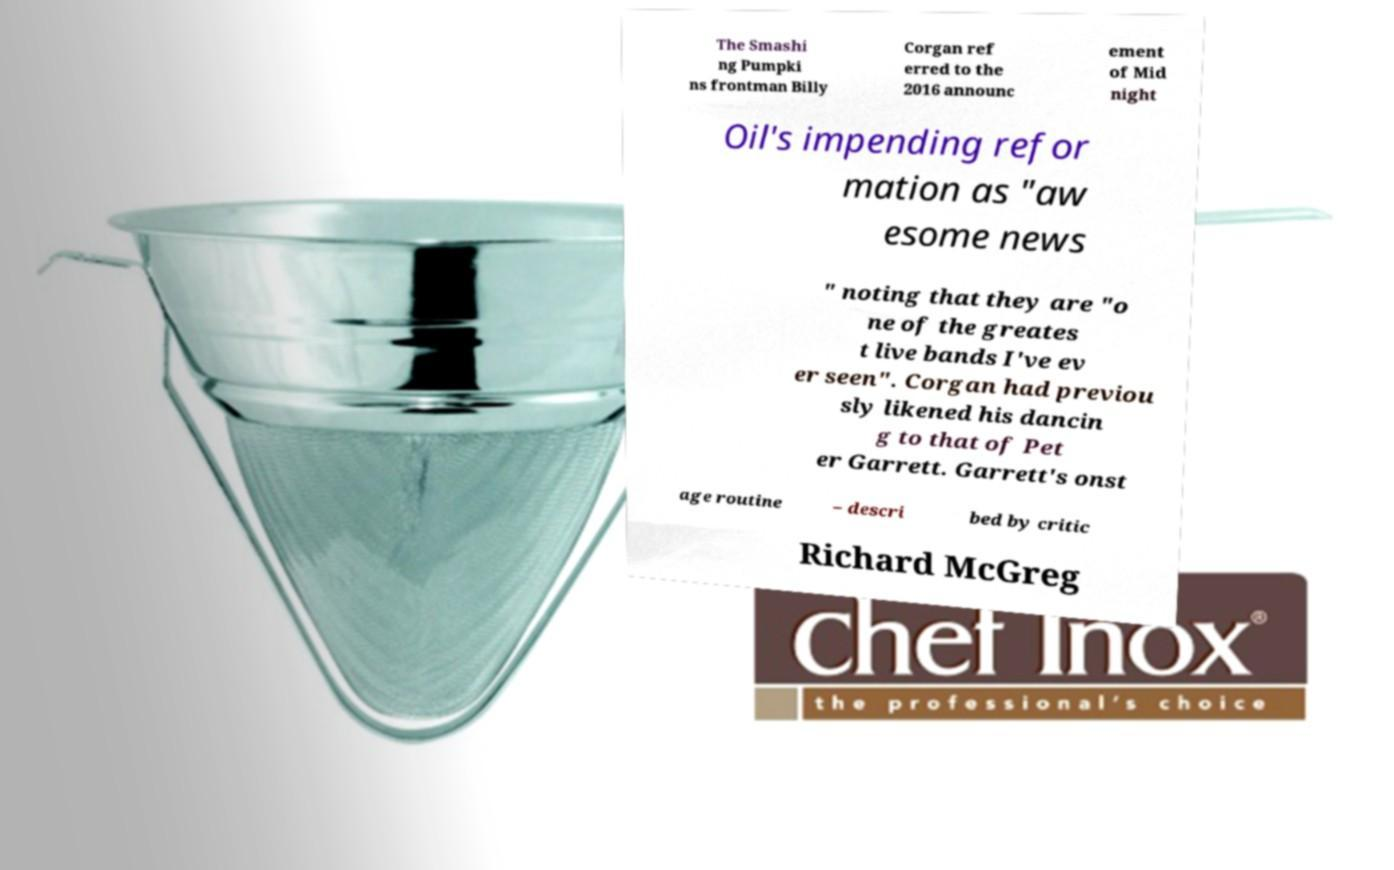For documentation purposes, I need the text within this image transcribed. Could you provide that? The Smashi ng Pumpki ns frontman Billy Corgan ref erred to the 2016 announc ement of Mid night Oil's impending refor mation as "aw esome news " noting that they are "o ne of the greates t live bands I've ev er seen". Corgan had previou sly likened his dancin g to that of Pet er Garrett. Garrett's onst age routine – descri bed by critic Richard McGreg 